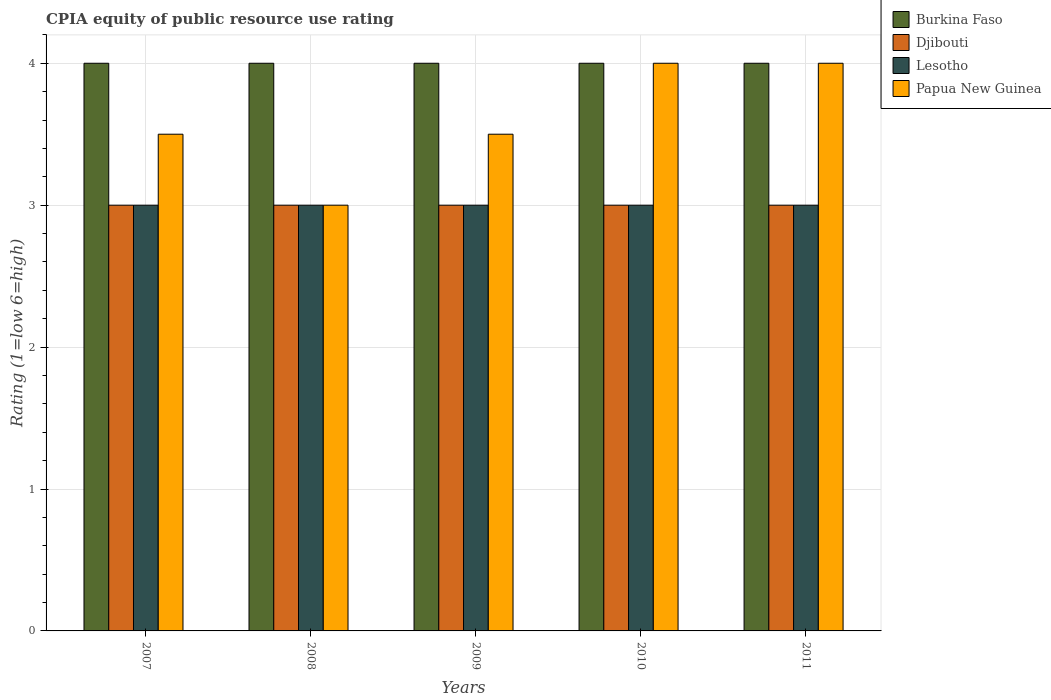How many different coloured bars are there?
Give a very brief answer. 4. Are the number of bars per tick equal to the number of legend labels?
Ensure brevity in your answer.  Yes. How many bars are there on the 2nd tick from the left?
Keep it short and to the point. 4. How many bars are there on the 4th tick from the right?
Offer a very short reply. 4. What is the CPIA rating in Djibouti in 2009?
Keep it short and to the point. 3. Across all years, what is the maximum CPIA rating in Lesotho?
Offer a very short reply. 3. Across all years, what is the minimum CPIA rating in Burkina Faso?
Give a very brief answer. 4. In which year was the CPIA rating in Lesotho maximum?
Provide a succinct answer. 2007. In which year was the CPIA rating in Burkina Faso minimum?
Offer a terse response. 2007. What is the total CPIA rating in Lesotho in the graph?
Offer a very short reply. 15. What is the difference between the CPIA rating in Papua New Guinea in 2010 and the CPIA rating in Djibouti in 2009?
Keep it short and to the point. 1. In the year 2007, what is the difference between the CPIA rating in Djibouti and CPIA rating in Lesotho?
Your response must be concise. 0. In how many years, is the CPIA rating in Lesotho greater than 3.2?
Keep it short and to the point. 0. Is the CPIA rating in Burkina Faso in 2008 less than that in 2009?
Offer a terse response. No. Is the difference between the CPIA rating in Djibouti in 2009 and 2010 greater than the difference between the CPIA rating in Lesotho in 2009 and 2010?
Make the answer very short. No. In how many years, is the CPIA rating in Lesotho greater than the average CPIA rating in Lesotho taken over all years?
Your answer should be compact. 0. Is the sum of the CPIA rating in Djibouti in 2008 and 2009 greater than the maximum CPIA rating in Papua New Guinea across all years?
Your response must be concise. Yes. Is it the case that in every year, the sum of the CPIA rating in Lesotho and CPIA rating in Djibouti is greater than the sum of CPIA rating in Burkina Faso and CPIA rating in Papua New Guinea?
Your answer should be very brief. No. What does the 1st bar from the left in 2010 represents?
Offer a very short reply. Burkina Faso. What does the 4th bar from the right in 2008 represents?
Provide a short and direct response. Burkina Faso. Are all the bars in the graph horizontal?
Your answer should be compact. No. Are the values on the major ticks of Y-axis written in scientific E-notation?
Ensure brevity in your answer.  No. Does the graph contain any zero values?
Offer a terse response. No. Does the graph contain grids?
Make the answer very short. Yes. What is the title of the graph?
Provide a succinct answer. CPIA equity of public resource use rating. Does "Somalia" appear as one of the legend labels in the graph?
Offer a very short reply. No. What is the label or title of the Y-axis?
Your answer should be very brief. Rating (1=low 6=high). What is the Rating (1=low 6=high) in Djibouti in 2007?
Offer a terse response. 3. What is the Rating (1=low 6=high) in Lesotho in 2007?
Ensure brevity in your answer.  3. What is the Rating (1=low 6=high) of Burkina Faso in 2008?
Offer a very short reply. 4. What is the Rating (1=low 6=high) in Papua New Guinea in 2008?
Offer a very short reply. 3. What is the Rating (1=low 6=high) of Djibouti in 2010?
Your answer should be very brief. 3. What is the Rating (1=low 6=high) of Papua New Guinea in 2010?
Keep it short and to the point. 4. What is the Rating (1=low 6=high) of Burkina Faso in 2011?
Give a very brief answer. 4. Across all years, what is the maximum Rating (1=low 6=high) in Djibouti?
Provide a succinct answer. 3. Across all years, what is the maximum Rating (1=low 6=high) of Lesotho?
Provide a short and direct response. 3. Across all years, what is the maximum Rating (1=low 6=high) of Papua New Guinea?
Keep it short and to the point. 4. Across all years, what is the minimum Rating (1=low 6=high) in Lesotho?
Make the answer very short. 3. Across all years, what is the minimum Rating (1=low 6=high) in Papua New Guinea?
Provide a short and direct response. 3. What is the total Rating (1=low 6=high) of Lesotho in the graph?
Give a very brief answer. 15. What is the total Rating (1=low 6=high) in Papua New Guinea in the graph?
Give a very brief answer. 18. What is the difference between the Rating (1=low 6=high) in Papua New Guinea in 2007 and that in 2008?
Offer a very short reply. 0.5. What is the difference between the Rating (1=low 6=high) in Burkina Faso in 2007 and that in 2009?
Make the answer very short. 0. What is the difference between the Rating (1=low 6=high) in Lesotho in 2007 and that in 2009?
Make the answer very short. 0. What is the difference between the Rating (1=low 6=high) of Burkina Faso in 2007 and that in 2010?
Offer a terse response. 0. What is the difference between the Rating (1=low 6=high) of Djibouti in 2007 and that in 2010?
Your answer should be compact. 0. What is the difference between the Rating (1=low 6=high) in Lesotho in 2007 and that in 2010?
Provide a succinct answer. 0. What is the difference between the Rating (1=low 6=high) of Papua New Guinea in 2007 and that in 2010?
Offer a terse response. -0.5. What is the difference between the Rating (1=low 6=high) in Burkina Faso in 2007 and that in 2011?
Provide a succinct answer. 0. What is the difference between the Rating (1=low 6=high) of Lesotho in 2007 and that in 2011?
Keep it short and to the point. 0. What is the difference between the Rating (1=low 6=high) in Papua New Guinea in 2007 and that in 2011?
Give a very brief answer. -0.5. What is the difference between the Rating (1=low 6=high) in Burkina Faso in 2008 and that in 2009?
Offer a terse response. 0. What is the difference between the Rating (1=low 6=high) of Lesotho in 2008 and that in 2009?
Offer a very short reply. 0. What is the difference between the Rating (1=low 6=high) of Papua New Guinea in 2008 and that in 2009?
Offer a terse response. -0.5. What is the difference between the Rating (1=low 6=high) of Lesotho in 2008 and that in 2010?
Your answer should be very brief. 0. What is the difference between the Rating (1=low 6=high) of Papua New Guinea in 2008 and that in 2010?
Provide a short and direct response. -1. What is the difference between the Rating (1=low 6=high) in Burkina Faso in 2008 and that in 2011?
Your answer should be very brief. 0. What is the difference between the Rating (1=low 6=high) of Lesotho in 2008 and that in 2011?
Give a very brief answer. 0. What is the difference between the Rating (1=low 6=high) of Papua New Guinea in 2008 and that in 2011?
Your response must be concise. -1. What is the difference between the Rating (1=low 6=high) in Djibouti in 2009 and that in 2010?
Provide a succinct answer. 0. What is the difference between the Rating (1=low 6=high) of Lesotho in 2009 and that in 2010?
Keep it short and to the point. 0. What is the difference between the Rating (1=low 6=high) of Papua New Guinea in 2009 and that in 2010?
Your answer should be compact. -0.5. What is the difference between the Rating (1=low 6=high) of Burkina Faso in 2009 and that in 2011?
Make the answer very short. 0. What is the difference between the Rating (1=low 6=high) of Djibouti in 2009 and that in 2011?
Your response must be concise. 0. What is the difference between the Rating (1=low 6=high) of Burkina Faso in 2010 and that in 2011?
Keep it short and to the point. 0. What is the difference between the Rating (1=low 6=high) of Lesotho in 2010 and that in 2011?
Give a very brief answer. 0. What is the difference between the Rating (1=low 6=high) of Papua New Guinea in 2010 and that in 2011?
Offer a very short reply. 0. What is the difference between the Rating (1=low 6=high) in Burkina Faso in 2007 and the Rating (1=low 6=high) in Djibouti in 2008?
Offer a terse response. 1. What is the difference between the Rating (1=low 6=high) of Djibouti in 2007 and the Rating (1=low 6=high) of Lesotho in 2008?
Ensure brevity in your answer.  0. What is the difference between the Rating (1=low 6=high) of Burkina Faso in 2007 and the Rating (1=low 6=high) of Lesotho in 2009?
Provide a succinct answer. 1. What is the difference between the Rating (1=low 6=high) of Burkina Faso in 2007 and the Rating (1=low 6=high) of Papua New Guinea in 2009?
Make the answer very short. 0.5. What is the difference between the Rating (1=low 6=high) of Lesotho in 2007 and the Rating (1=low 6=high) of Papua New Guinea in 2009?
Your answer should be compact. -0.5. What is the difference between the Rating (1=low 6=high) of Burkina Faso in 2007 and the Rating (1=low 6=high) of Djibouti in 2010?
Offer a very short reply. 1. What is the difference between the Rating (1=low 6=high) of Burkina Faso in 2007 and the Rating (1=low 6=high) of Lesotho in 2010?
Offer a very short reply. 1. What is the difference between the Rating (1=low 6=high) in Djibouti in 2007 and the Rating (1=low 6=high) in Papua New Guinea in 2010?
Offer a very short reply. -1. What is the difference between the Rating (1=low 6=high) of Burkina Faso in 2007 and the Rating (1=low 6=high) of Djibouti in 2011?
Your response must be concise. 1. What is the difference between the Rating (1=low 6=high) in Burkina Faso in 2007 and the Rating (1=low 6=high) in Lesotho in 2011?
Offer a very short reply. 1. What is the difference between the Rating (1=low 6=high) in Djibouti in 2007 and the Rating (1=low 6=high) in Lesotho in 2011?
Make the answer very short. 0. What is the difference between the Rating (1=low 6=high) of Djibouti in 2007 and the Rating (1=low 6=high) of Papua New Guinea in 2011?
Offer a terse response. -1. What is the difference between the Rating (1=low 6=high) in Burkina Faso in 2008 and the Rating (1=low 6=high) in Djibouti in 2009?
Provide a short and direct response. 1. What is the difference between the Rating (1=low 6=high) in Burkina Faso in 2008 and the Rating (1=low 6=high) in Papua New Guinea in 2009?
Your answer should be very brief. 0.5. What is the difference between the Rating (1=low 6=high) in Djibouti in 2008 and the Rating (1=low 6=high) in Papua New Guinea in 2009?
Offer a very short reply. -0.5. What is the difference between the Rating (1=low 6=high) of Burkina Faso in 2008 and the Rating (1=low 6=high) of Djibouti in 2010?
Provide a succinct answer. 1. What is the difference between the Rating (1=low 6=high) of Lesotho in 2008 and the Rating (1=low 6=high) of Papua New Guinea in 2010?
Give a very brief answer. -1. What is the difference between the Rating (1=low 6=high) in Burkina Faso in 2008 and the Rating (1=low 6=high) in Lesotho in 2011?
Offer a terse response. 1. What is the difference between the Rating (1=low 6=high) of Burkina Faso in 2009 and the Rating (1=low 6=high) of Djibouti in 2010?
Make the answer very short. 1. What is the difference between the Rating (1=low 6=high) of Djibouti in 2009 and the Rating (1=low 6=high) of Lesotho in 2010?
Give a very brief answer. 0. What is the difference between the Rating (1=low 6=high) in Lesotho in 2009 and the Rating (1=low 6=high) in Papua New Guinea in 2010?
Give a very brief answer. -1. What is the difference between the Rating (1=low 6=high) in Burkina Faso in 2009 and the Rating (1=low 6=high) in Djibouti in 2011?
Provide a succinct answer. 1. What is the difference between the Rating (1=low 6=high) of Burkina Faso in 2009 and the Rating (1=low 6=high) of Lesotho in 2011?
Provide a short and direct response. 1. What is the difference between the Rating (1=low 6=high) of Burkina Faso in 2009 and the Rating (1=low 6=high) of Papua New Guinea in 2011?
Ensure brevity in your answer.  0. What is the difference between the Rating (1=low 6=high) in Djibouti in 2009 and the Rating (1=low 6=high) in Lesotho in 2011?
Provide a short and direct response. 0. What is the difference between the Rating (1=low 6=high) in Djibouti in 2009 and the Rating (1=low 6=high) in Papua New Guinea in 2011?
Provide a succinct answer. -1. What is the difference between the Rating (1=low 6=high) in Burkina Faso in 2010 and the Rating (1=low 6=high) in Djibouti in 2011?
Give a very brief answer. 1. What is the difference between the Rating (1=low 6=high) in Burkina Faso in 2010 and the Rating (1=low 6=high) in Papua New Guinea in 2011?
Ensure brevity in your answer.  0. What is the difference between the Rating (1=low 6=high) of Djibouti in 2010 and the Rating (1=low 6=high) of Papua New Guinea in 2011?
Keep it short and to the point. -1. What is the difference between the Rating (1=low 6=high) in Lesotho in 2010 and the Rating (1=low 6=high) in Papua New Guinea in 2011?
Your answer should be very brief. -1. What is the average Rating (1=low 6=high) of Lesotho per year?
Make the answer very short. 3. What is the average Rating (1=low 6=high) of Papua New Guinea per year?
Make the answer very short. 3.6. In the year 2007, what is the difference between the Rating (1=low 6=high) in Burkina Faso and Rating (1=low 6=high) in Djibouti?
Provide a short and direct response. 1. In the year 2007, what is the difference between the Rating (1=low 6=high) of Burkina Faso and Rating (1=low 6=high) of Lesotho?
Provide a succinct answer. 1. In the year 2007, what is the difference between the Rating (1=low 6=high) in Burkina Faso and Rating (1=low 6=high) in Papua New Guinea?
Give a very brief answer. 0.5. In the year 2007, what is the difference between the Rating (1=low 6=high) in Djibouti and Rating (1=low 6=high) in Lesotho?
Ensure brevity in your answer.  0. In the year 2007, what is the difference between the Rating (1=low 6=high) in Lesotho and Rating (1=low 6=high) in Papua New Guinea?
Your answer should be very brief. -0.5. In the year 2008, what is the difference between the Rating (1=low 6=high) in Burkina Faso and Rating (1=low 6=high) in Lesotho?
Provide a short and direct response. 1. In the year 2008, what is the difference between the Rating (1=low 6=high) of Burkina Faso and Rating (1=low 6=high) of Papua New Guinea?
Your response must be concise. 1. In the year 2008, what is the difference between the Rating (1=low 6=high) of Djibouti and Rating (1=low 6=high) of Lesotho?
Provide a succinct answer. 0. In the year 2008, what is the difference between the Rating (1=low 6=high) of Lesotho and Rating (1=low 6=high) of Papua New Guinea?
Make the answer very short. 0. In the year 2009, what is the difference between the Rating (1=low 6=high) in Burkina Faso and Rating (1=low 6=high) in Djibouti?
Give a very brief answer. 1. In the year 2009, what is the difference between the Rating (1=low 6=high) in Burkina Faso and Rating (1=low 6=high) in Lesotho?
Provide a short and direct response. 1. In the year 2009, what is the difference between the Rating (1=low 6=high) in Burkina Faso and Rating (1=low 6=high) in Papua New Guinea?
Your answer should be compact. 0.5. In the year 2009, what is the difference between the Rating (1=low 6=high) in Djibouti and Rating (1=low 6=high) in Lesotho?
Provide a short and direct response. 0. In the year 2011, what is the difference between the Rating (1=low 6=high) in Burkina Faso and Rating (1=low 6=high) in Lesotho?
Ensure brevity in your answer.  1. In the year 2011, what is the difference between the Rating (1=low 6=high) of Djibouti and Rating (1=low 6=high) of Lesotho?
Provide a succinct answer. 0. In the year 2011, what is the difference between the Rating (1=low 6=high) of Djibouti and Rating (1=low 6=high) of Papua New Guinea?
Your answer should be compact. -1. What is the ratio of the Rating (1=low 6=high) in Burkina Faso in 2007 to that in 2008?
Your response must be concise. 1. What is the ratio of the Rating (1=low 6=high) of Djibouti in 2007 to that in 2008?
Offer a terse response. 1. What is the ratio of the Rating (1=low 6=high) of Lesotho in 2007 to that in 2009?
Make the answer very short. 1. What is the ratio of the Rating (1=low 6=high) in Djibouti in 2007 to that in 2010?
Keep it short and to the point. 1. What is the ratio of the Rating (1=low 6=high) in Burkina Faso in 2007 to that in 2011?
Your answer should be very brief. 1. What is the ratio of the Rating (1=low 6=high) of Lesotho in 2008 to that in 2009?
Offer a terse response. 1. What is the ratio of the Rating (1=low 6=high) of Papua New Guinea in 2008 to that in 2009?
Give a very brief answer. 0.86. What is the ratio of the Rating (1=low 6=high) in Djibouti in 2008 to that in 2010?
Your answer should be compact. 1. What is the ratio of the Rating (1=low 6=high) in Lesotho in 2008 to that in 2010?
Keep it short and to the point. 1. What is the ratio of the Rating (1=low 6=high) of Papua New Guinea in 2008 to that in 2010?
Offer a very short reply. 0.75. What is the ratio of the Rating (1=low 6=high) in Burkina Faso in 2008 to that in 2011?
Your answer should be very brief. 1. What is the ratio of the Rating (1=low 6=high) in Papua New Guinea in 2008 to that in 2011?
Your response must be concise. 0.75. What is the ratio of the Rating (1=low 6=high) of Papua New Guinea in 2009 to that in 2010?
Keep it short and to the point. 0.88. What is the ratio of the Rating (1=low 6=high) of Lesotho in 2009 to that in 2011?
Provide a short and direct response. 1. What is the ratio of the Rating (1=low 6=high) of Papua New Guinea in 2009 to that in 2011?
Give a very brief answer. 0.88. What is the ratio of the Rating (1=low 6=high) in Burkina Faso in 2010 to that in 2011?
Provide a short and direct response. 1. What is the ratio of the Rating (1=low 6=high) of Papua New Guinea in 2010 to that in 2011?
Ensure brevity in your answer.  1. What is the difference between the highest and the second highest Rating (1=low 6=high) in Djibouti?
Your answer should be compact. 0. What is the difference between the highest and the second highest Rating (1=low 6=high) of Lesotho?
Keep it short and to the point. 0. What is the difference between the highest and the lowest Rating (1=low 6=high) of Burkina Faso?
Ensure brevity in your answer.  0. What is the difference between the highest and the lowest Rating (1=low 6=high) of Lesotho?
Keep it short and to the point. 0. 